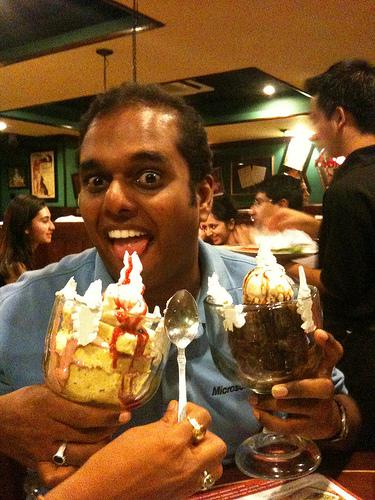Question: how many glasses?
Choices:
A. 2.
B. 1.
C. 5.
D. 9.
Answer with the letter. Answer: A Question: what is the man eating?
Choices:
A. Ice cream.
B. Cheese burger.
C. Tuna fish.
D. Cheesecake.
Answer with the letter. Answer: A Question: why is the man smiling?
Choices:
A. Haning with friends.
B. Watching a woman.
C. Eating ice cream.
D. Watching the game.
Answer with the letter. Answer: C Question: what is behind the man?
Choices:
A. A building.
B. A car.
C. A streetlight.
D. People.
Answer with the letter. Answer: D Question: who is in front of the people?
Choices:
A. The man.
B. The woman.
C. The boy.
D. The girl.
Answer with the letter. Answer: A Question: what color is the spoon?
Choices:
A. Gold.
B. Silver.
C. White.
D. Transparent.
Answer with the letter. Answer: B 